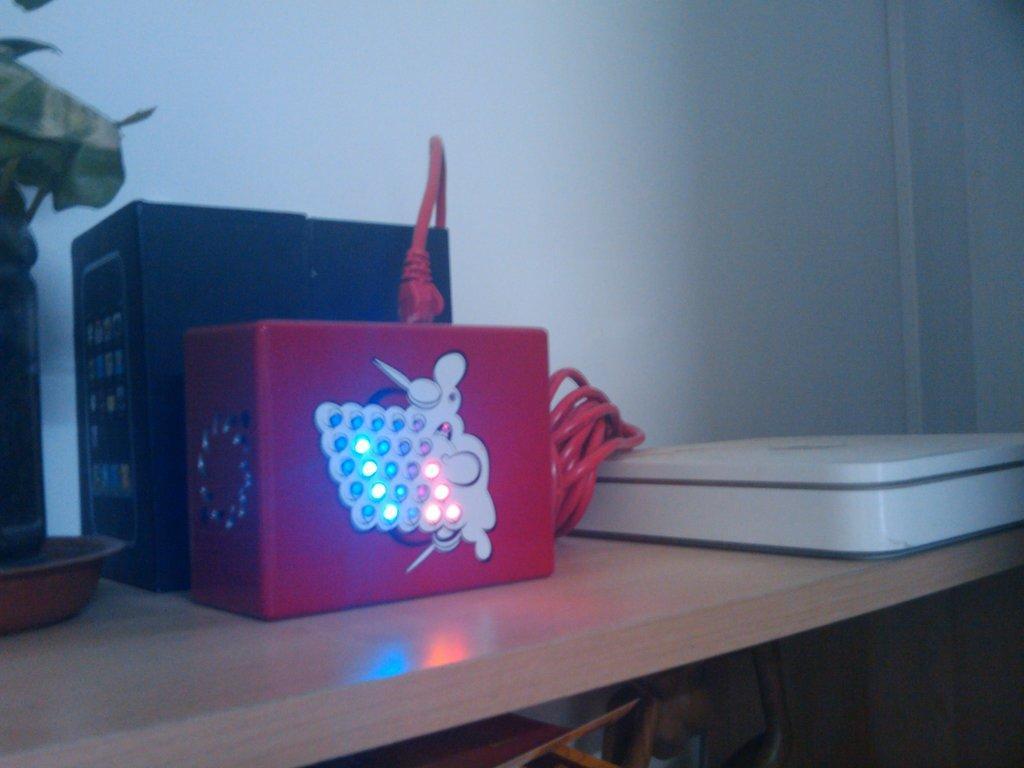Please provide a concise description of this image. In this image we can see electronic objects, cable, plant in a bottle in the plate are on a wooden platform. We can see the wall and objects. 